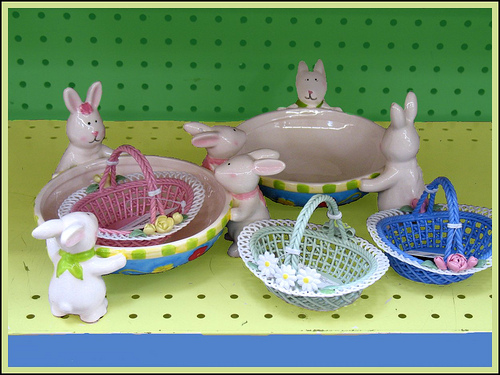<image>
Is the plate above the basket? No. The plate is not positioned above the basket. The vertical arrangement shows a different relationship. 